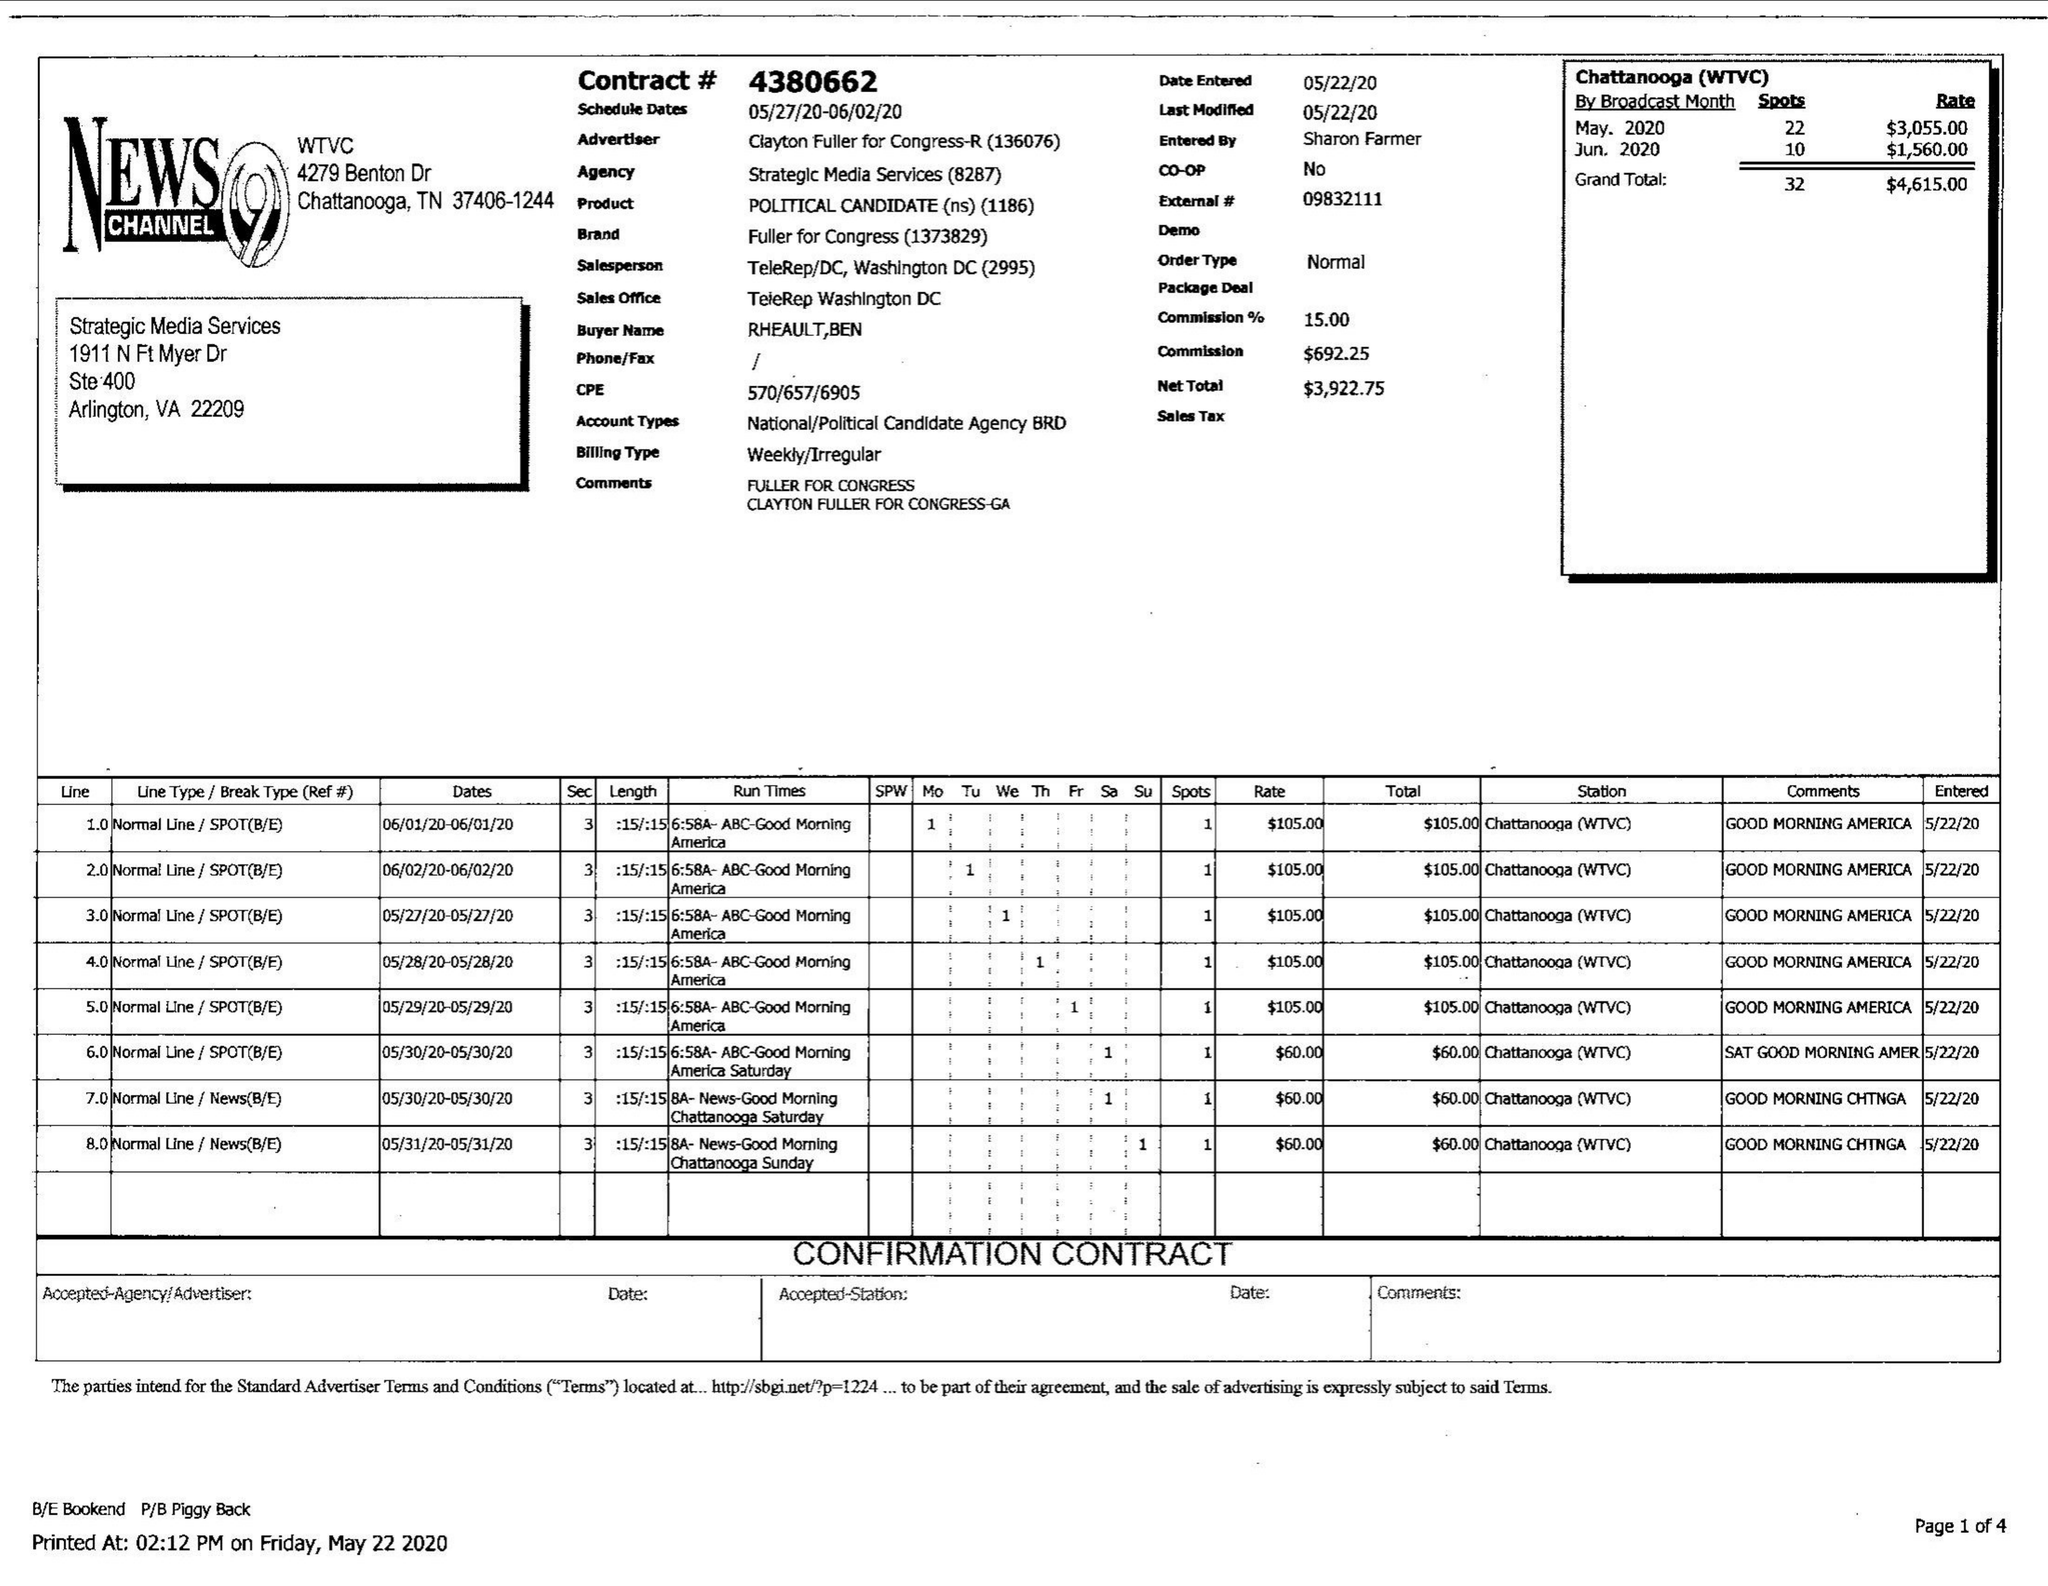What is the value for the contract_num?
Answer the question using a single word or phrase. 4380662 